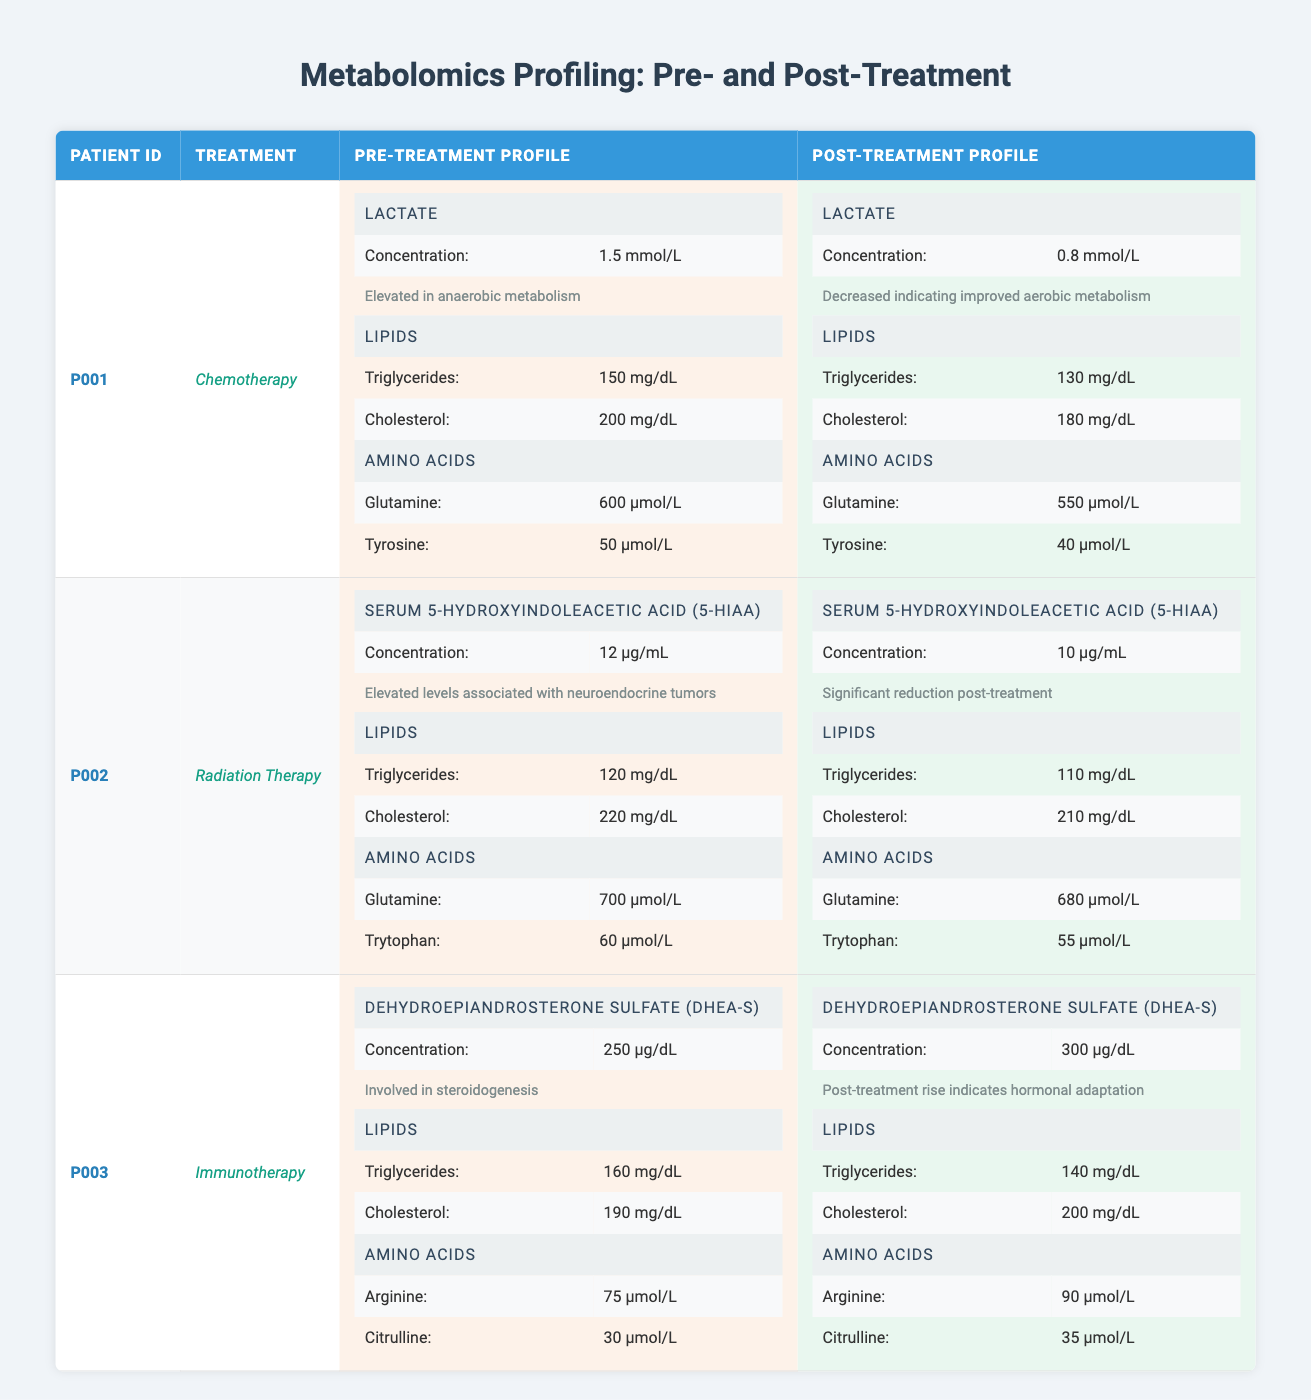What is the pre-treatment concentration of Lactate for Patient P001? The table shows that under the Pre-Treatment Profile for Patient P001, the Lactate concentration is listed as 1.5 mmol/L.
Answer: 1.5 mmol/L What is the post-treatment concentration of serum 5-Hydroxyindoleacetic Acid (5-HIAA) for Patient P002? From the table, for Patient P002 in the Post-Treatment Profile, the concentration of serum 5-HIAA is recorded as 10 µg/mL.
Answer: 10 µg/mL Did the cholesterol level for Patient P003 increase or decrease after treatment? Referring to the Lipids section, the cholesterol level for Patient P003 in the Post-Treatment Profile is 200 mg/dL, while it was 190 mg/dL pre-treatment. This indicates an increase.
Answer: Increase What is the difference in triglyceride levels for Patient P001 before and after treatment? For Patient P001, the Pre-Treatment triglyceride level is 150 mg/dL, and the Post-Treatment level is 130 mg/dL. The difference is calculated as 150 - 130 = 20 mg/dL.
Answer: 20 mg/dL Was the concentration of Glutamine higher in the pre-treatment or post-treatment profile for Patient P002? The table indicates that for Patient P002, Pre-Treatment Glutamine concentration is 700 µmol/L, while Post-Treatment it is 680 µmol/L. This shows that the pre-treatment level is higher.
Answer: Pre-treatment What are the significant changes in Lactate levels for Patient P001 after treatment? In the table, Patient P001 shows a decrease in Lactate concentration from 1.5 mmol/L (pre-treatment) to 0.8 mmol/L (post-treatment), indicating improved aerobic metabolism.
Answer: Decrease, improved aerobic metabolism What is the average concentration of Cholesterol across all patients after treatment? For post-treatment, Patient P001 has Cholesterol of 180 mg/dL, Patient P002 has 210 mg/dL, and Patient P003 has 200 mg/dL. The average is calculated as (180 + 210 + 200) / 3 = 196.67 mg/dL.
Answer: 196.67 mg/dL Did Patient P003 see a post-treatment rise in Dehydroepiandrosterone Sulfate (DHEA-S)? Looking at the data, the pre-treatment concentration for DHEA-S in Patient P003 is 250 µg/dL, which rises to 300 µg/dL post-treatment, confirming a rise.
Answer: Yes What is the relationship between the pre-treatment and post-treatment levels of Tyrosine for Patient P001? For Patient P001, Tyrosine is measured at 50 µmol/L pre-treatment and at 40 µmol/L post-treatment, demonstrating a decrease in this amino acid after treatment.
Answer: Decrease 